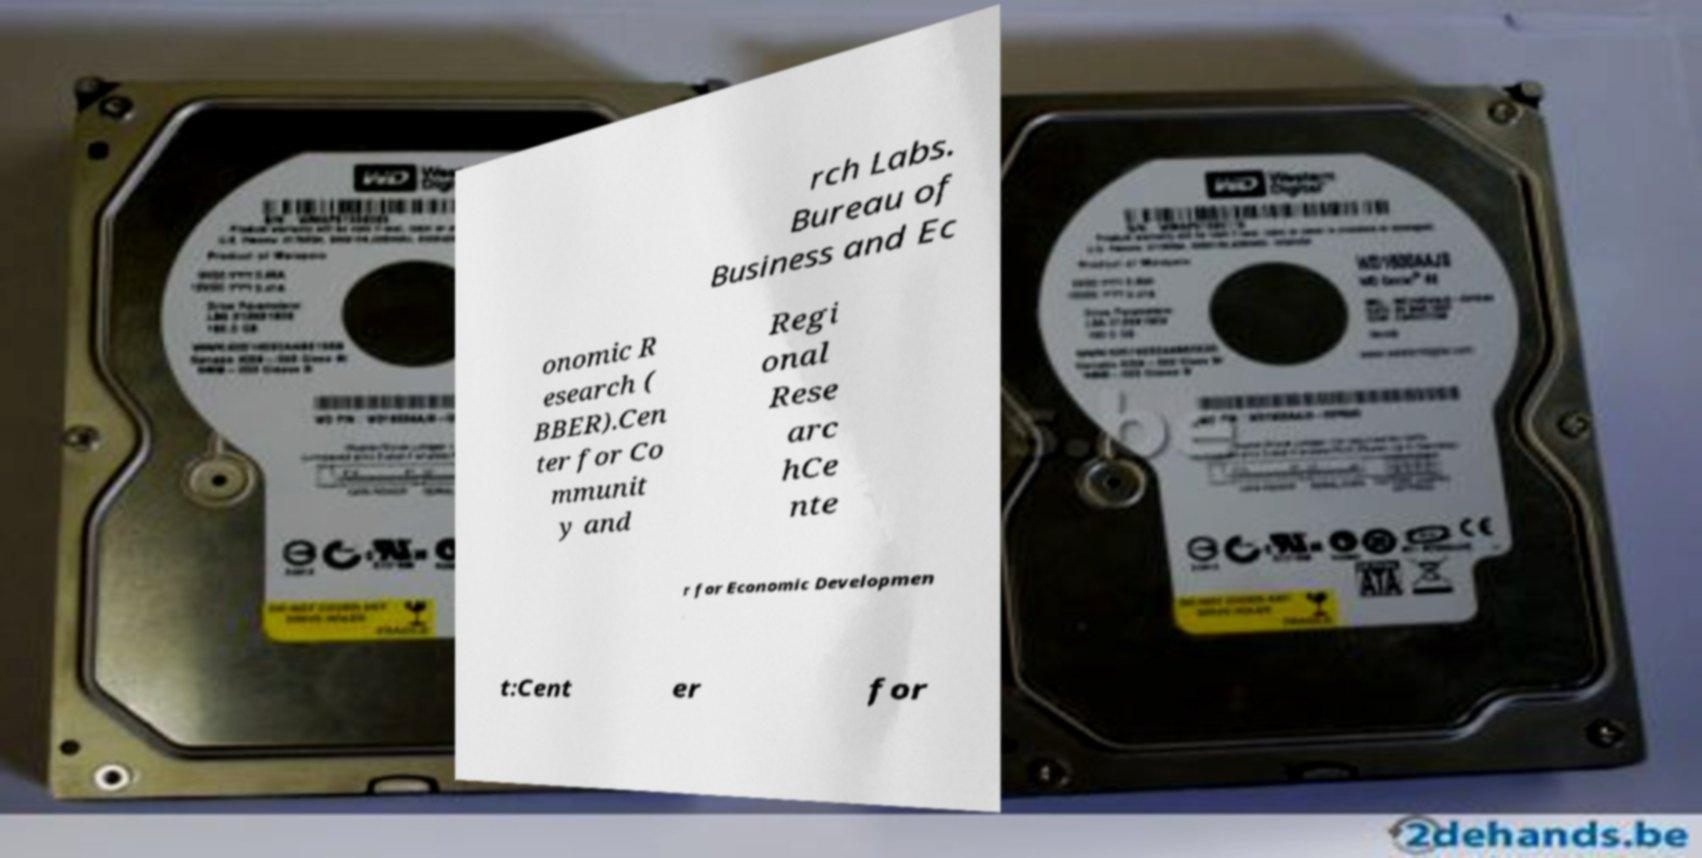Could you assist in decoding the text presented in this image and type it out clearly? rch Labs. Bureau of Business and Ec onomic R esearch ( BBER).Cen ter for Co mmunit y and Regi onal Rese arc hCe nte r for Economic Developmen t:Cent er for 